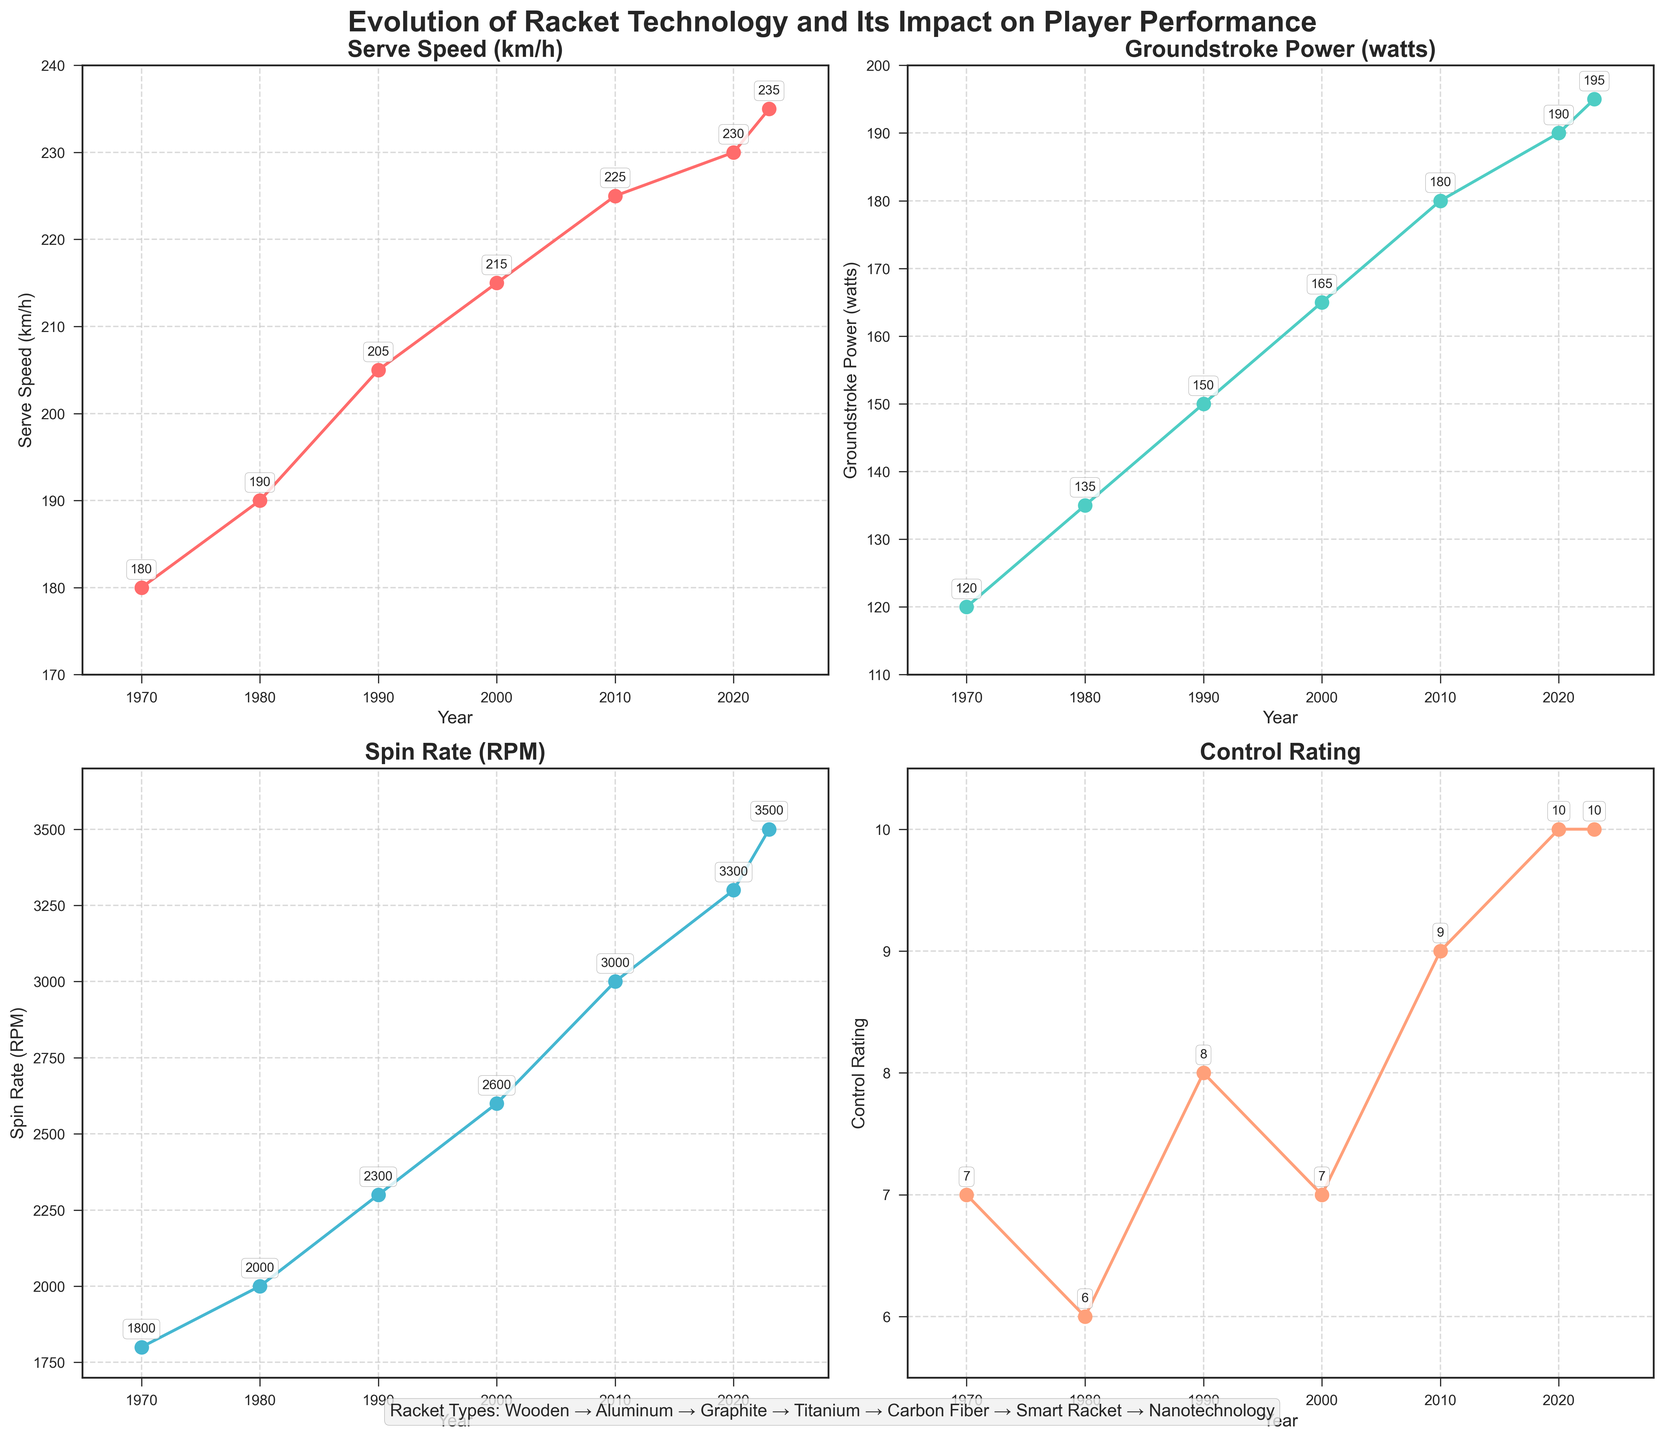What's the title of the figure? The title is written at the very top of the figure in bold and large font size.
Answer: "Evolution of Racket Technology and Its Impact on Player Performance" What year marks the introduction of Graphite rackets? The year corresponding to Graphite rackets can be seen on the x-axis of all subplots beside the label "Graphite" in the legend.
Answer: 1990 What is the control rating value for 2020? On the subplot with the title "Control Rating," find the point corresponding to the year 2020 and read its value.
Answer: 10 Which racket type showed the highest serve speed? Look at the subplot titled "Serve Speed (km/h)" and identify the maximum value; check the corresponding year and refer to the "Racket Types" text at the bottom to get the racket type.
Answer: Nanotechnology What's the average groundstroke power in the years 2000 and 2010? Identify the groundstroke power values for 2000 and 2010 from the subplot titled "Groundstroke Power (watts)." Add these values and divide by 2.
Answer: (165 + 180) / 2 = 172.5 How did spin rate change from 1980 to 1990? On the subplot titled "Spin Rate (RPM)," check the values for 1980 and 1990 and calculate the difference between them.
Answer: Spin rate in 1980 is 2000 RPM and in 1990 is 2300 RPM, difference = 2300 - 2000 = 300 Compare the control rating of rackets in 2010 and 2020. Which year had a higher rating? Refer to the "Control Rating" subplot and compare the values for the years 2010 and 2020.
Answer: 2020 had a higher rating (10 compared to 9) What's the overall trend in serve speeds from 1970 to 2023? Observe the "Serve Speed (km/h)" subplot, noting the general direction of the plotted line from 1970 to 2023.
Answer: Increasing trend How many major transitions in racket technology are shown in the figure? Count the distinct racket types listed in the "Racket Types" text at the bottom of the figure.
Answer: 7 transitions 